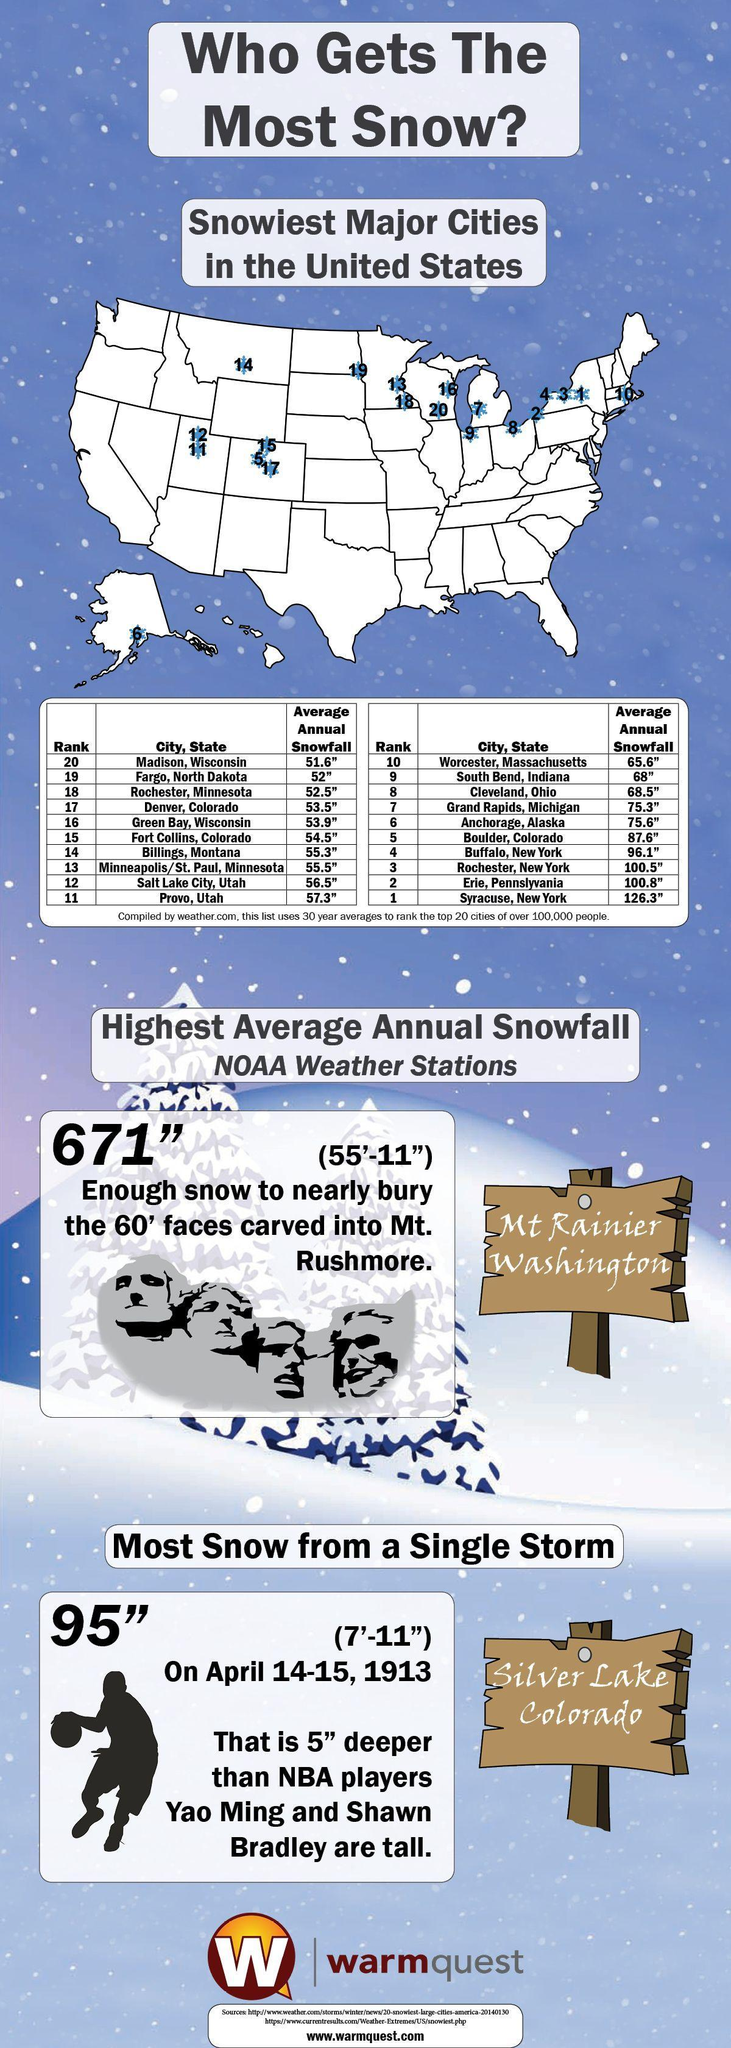What is the second least average annual snowfall recorded in U.S.?
Answer the question with a short phrase. 52" Which state records the second highest average annual snowfall in the United States? Erie, Pennslyvania Which City is ranked no '12' incase of average annual snowfall in U.S? Salt Lake City What is the average annual snowfall recorded in Worcester, Massachusetts? 65.6" What is the least average annual snowfall recorded in U.S.? 51.6" Which City records the highest average annual snowfall in the United States? Syracuse, New York 